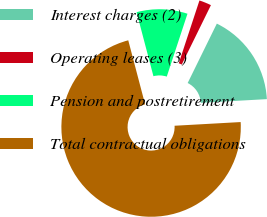Convert chart to OTSL. <chart><loc_0><loc_0><loc_500><loc_500><pie_chart><fcel>Interest charges (2)<fcel>Operating leases (3)<fcel>Pension and postretirement<fcel>Total contractual obligations<nl><fcel>16.85%<fcel>2.2%<fcel>9.16%<fcel>71.79%<nl></chart> 